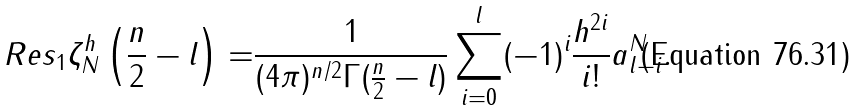<formula> <loc_0><loc_0><loc_500><loc_500>R e s _ { 1 } \zeta ^ { h } _ { N } \left ( \frac { n } { 2 } - l \right ) = & \frac { 1 } { ( 4 \pi ) ^ { n / 2 } \Gamma ( \frac { n } { 2 } - l ) } \sum _ { i = 0 } ^ { l } ( - 1 ) ^ { i } \frac { h ^ { 2 i } } { i ! } a ^ { N } _ { l - i } .</formula> 